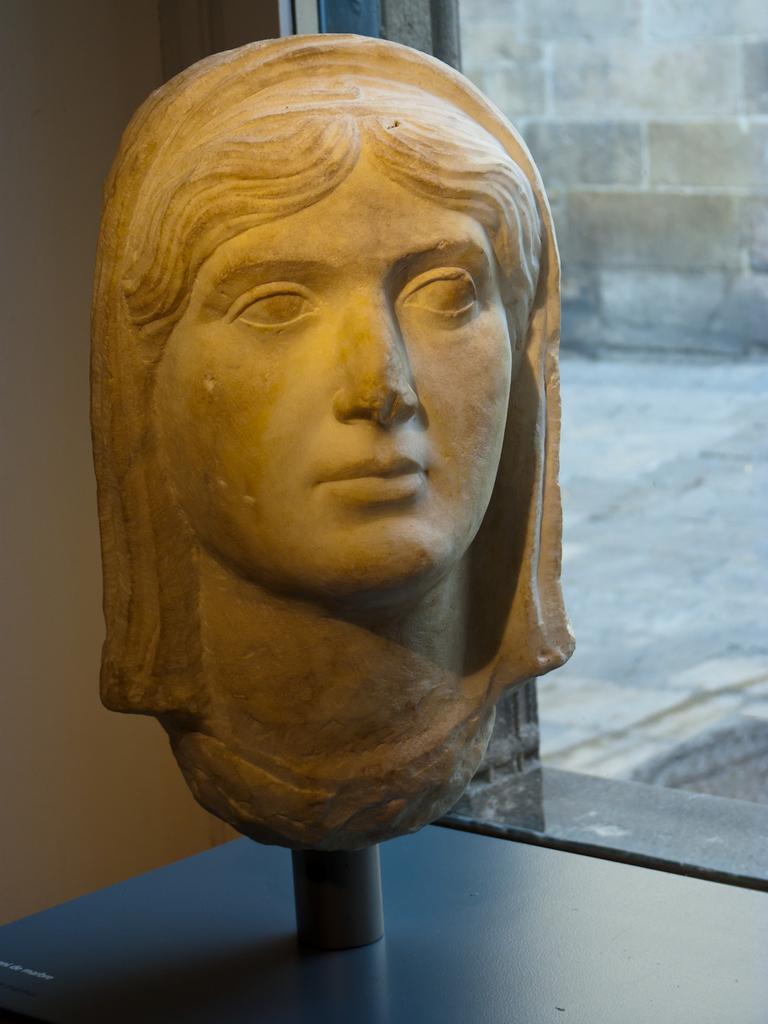Could you give a brief overview of what you see in this image? In this image, we can see a sculpture, rod and surface. Background we can see a wall. On the right side of the image, we can see walkway and wall. 